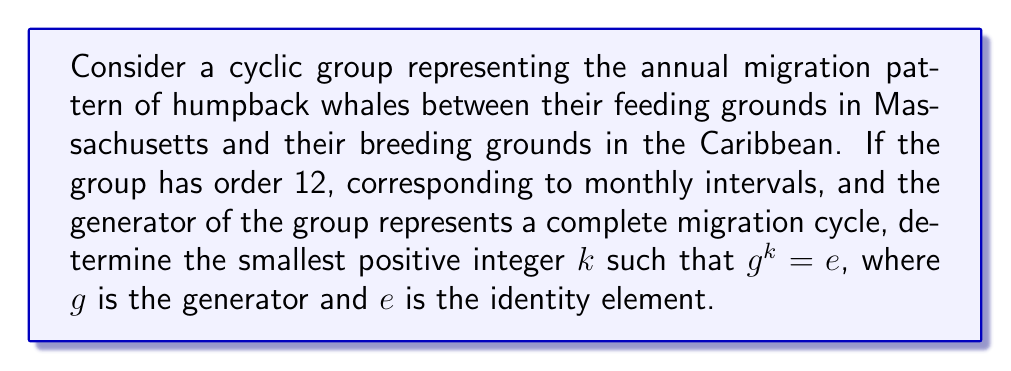Can you solve this math problem? To solve this problem, we need to understand the properties of cyclic groups and relate them to the whale migration pattern:

1) In a cyclic group of order 12, all elements can be expressed as powers of the generator $g$: $\{e, g, g^2, g^3, ..., g^{11}\}$.

2) The order of the group represents the number of distinct elements, which in this case corresponds to monthly intervals in the whale migration cycle.

3) The generator $g$ represents a complete migration cycle, which takes a full year (12 months) to complete.

4) In a cyclic group, the smallest positive integer $k$ such that $g^k = e$ is equal to the order of the group.

5) This is because:
   $$g^{12} = (g^1)^{12} = g^1 \cdot g^1 \cdot ... \cdot g^1 \text{ (12 times)} = e$$
   But for any $k < 12$, $g^k \neq e$.

6) This aligns with the biological reality: after 12 months, the whales return to their original position, completing a full migration cycle.

Therefore, the smallest positive integer $k$ such that $g^k = e$ is 12.
Answer: $k = 12$ 